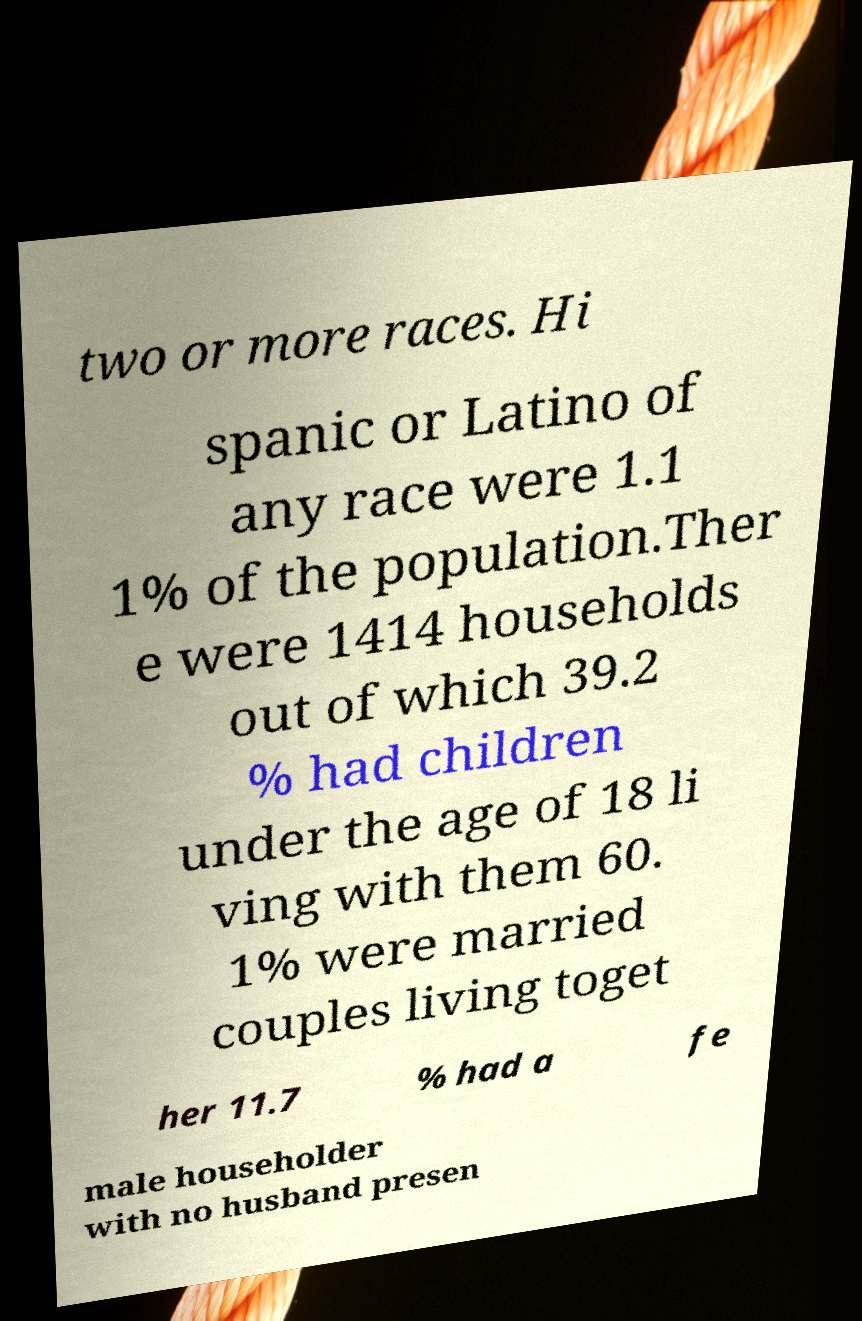Could you extract and type out the text from this image? two or more races. Hi spanic or Latino of any race were 1.1 1% of the population.Ther e were 1414 households out of which 39.2 % had children under the age of 18 li ving with them 60. 1% were married couples living toget her 11.7 % had a fe male householder with no husband presen 